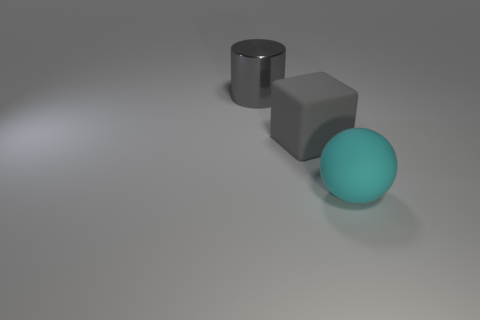Add 1 cylinders. How many objects exist? 4 Subtract 1 spheres. How many spheres are left? 0 Subtract all cylinders. How many objects are left? 2 Add 3 big rubber blocks. How many big rubber blocks exist? 4 Subtract 0 purple balls. How many objects are left? 3 Subtract all yellow spheres. Subtract all gray blocks. How many spheres are left? 1 Subtract all large cyan rubber things. Subtract all shiny cylinders. How many objects are left? 1 Add 1 large cyan matte spheres. How many large cyan matte spheres are left? 2 